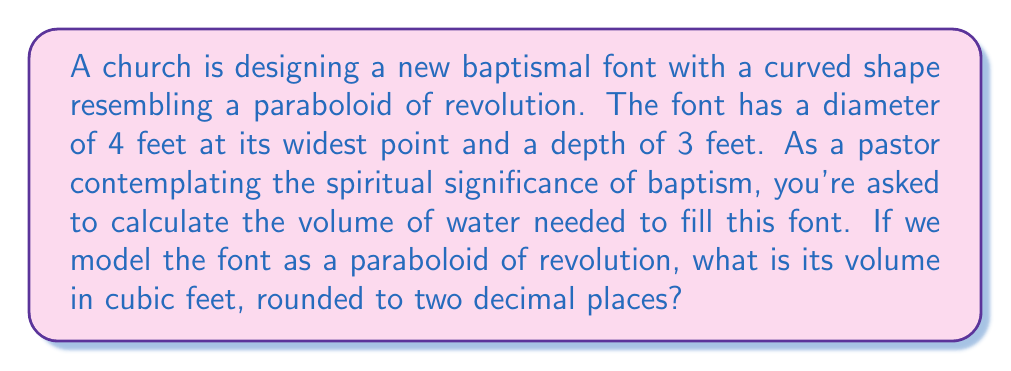Can you solve this math problem? To solve this problem, let's approach it step-by-step, considering both the mathematical and spiritual aspects:

1) The shape of the baptismal font is described as a paraboloid of revolution. This is symbolically significant, as the curved shape can represent the all-encompassing nature of God's love and grace in baptism.

2) The formula for the volume of a paraboloid of revolution is:

   $$V = \frac{1}{2} \pi r^2 h$$

   Where $r$ is the radius of the base and $h$ is the height.

3) We are given:
   - Diameter = 4 feet, so radius $r = 2$ feet
   - Depth (height) $h = 3$ feet

4) Let's substitute these values into our formula:

   $$V = \frac{1}{2} \pi (2)^2 (3)$$

5) Simplify:
   $$V = \frac{1}{2} \pi (4) (3)$$
   $$V = 6\pi$$

6) Calculate:
   $$V \approx 18.8495559215387...$$

7) Rounding to two decimal places:
   $$V \approx 18.85 \text{ cubic feet}$$

This volume represents not just the physical capacity of the font, but symbolically the abundance of God's grace poured out in baptism. The curved shape and the calculated volume remind us of the infinite nature of divine love, which cannot be contained or measured by human standards.
Answer: $18.85 \text{ cubic feet}$ 